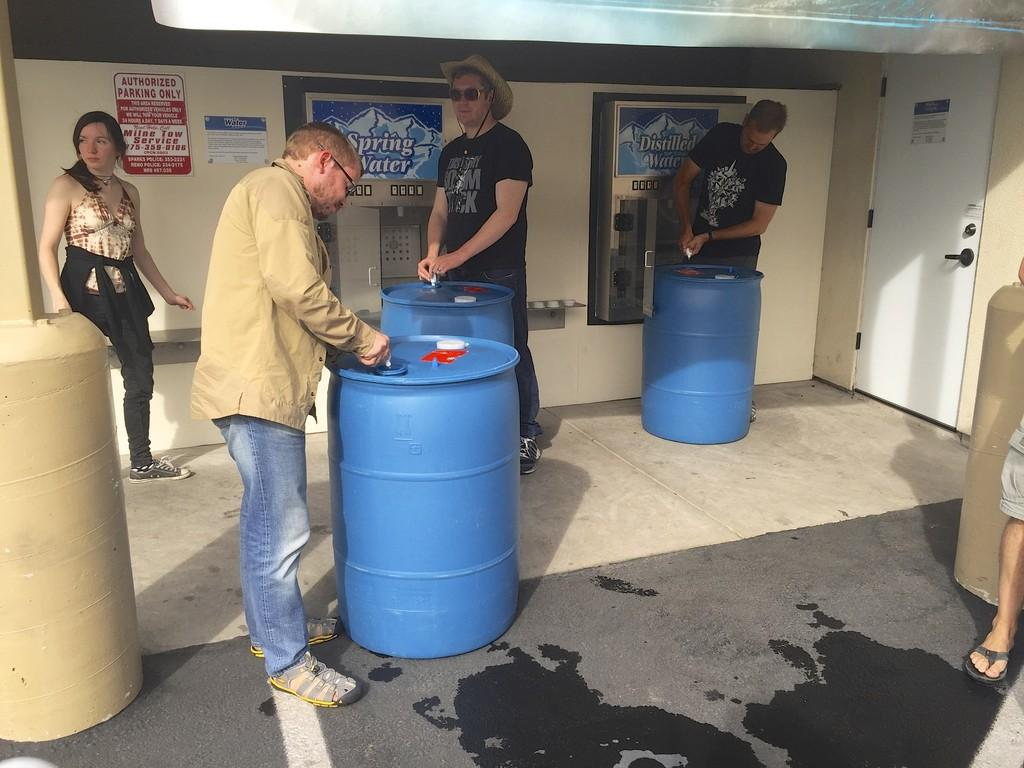<image>
Relay a brief, clear account of the picture shown. Four people working on 3 barrels under an overhang with Authorized Parking Only sign and Spring Water machine. 